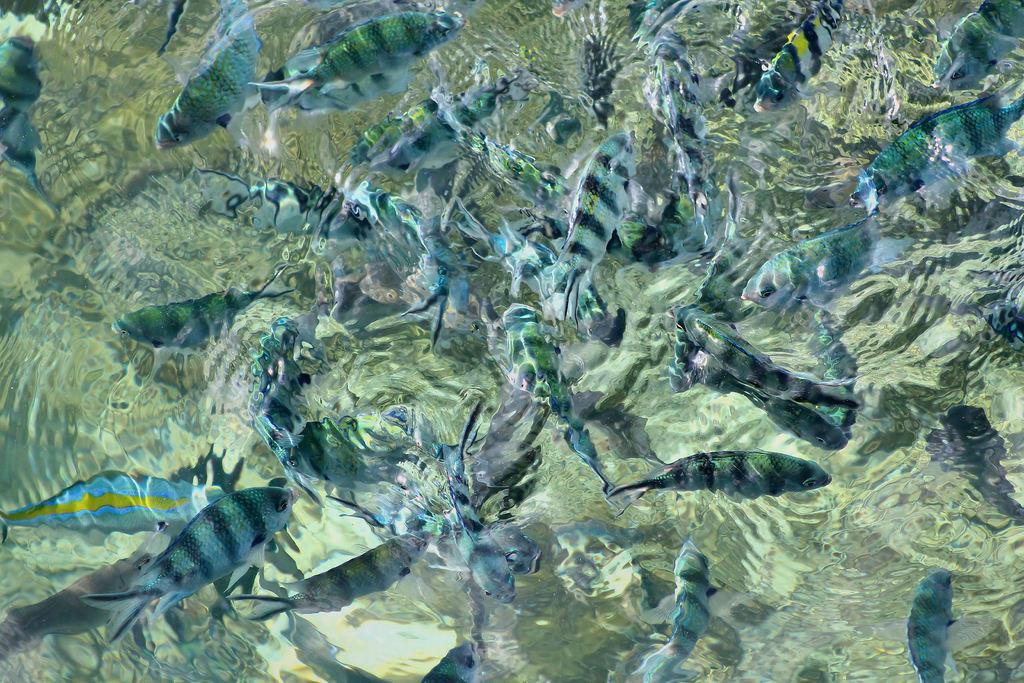Please provide a concise description of this image. In this image we can see fishes in the water. 